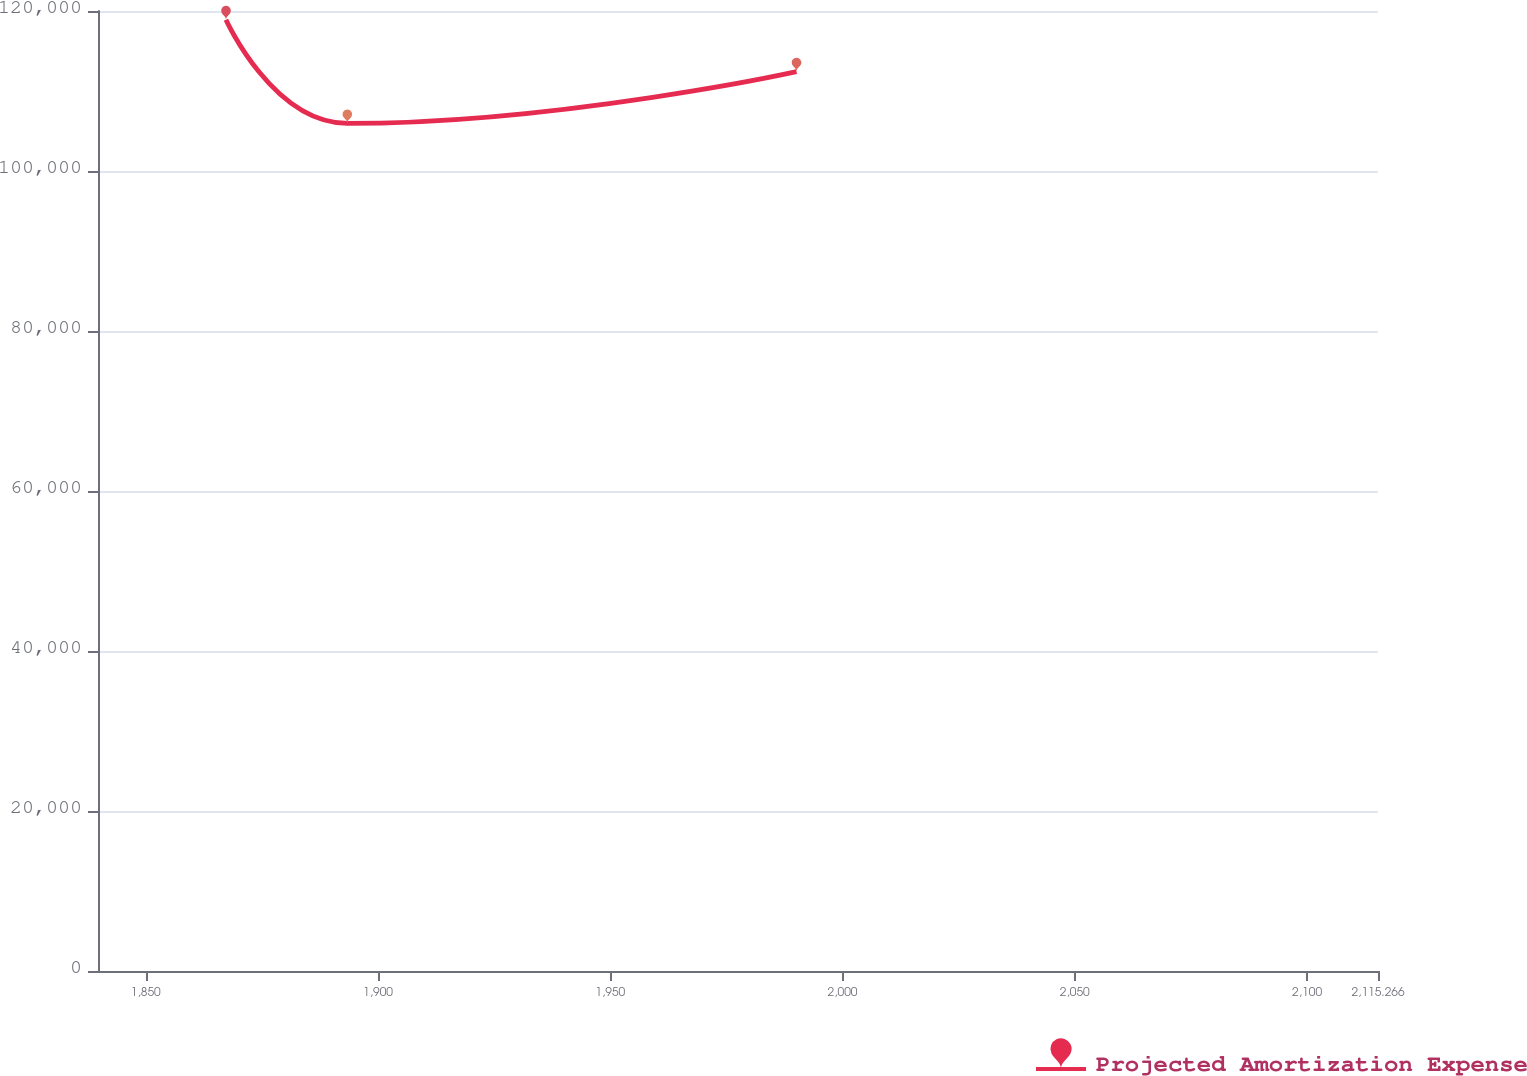Convert chart to OTSL. <chart><loc_0><loc_0><loc_500><loc_500><line_chart><ecel><fcel>Projected Amortization Expense<nl><fcel>1867.28<fcel>118902<nl><fcel>1893.4<fcel>105946<nl><fcel>1990.09<fcel>112424<nl><fcel>2116.7<fcel>69320.9<nl><fcel>2142.82<fcel>50405.8<nl></chart> 